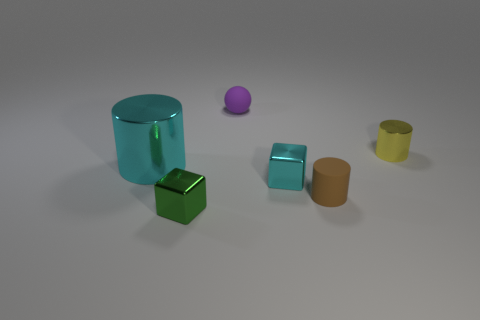Subtract all large cylinders. How many cylinders are left? 2 Add 3 small spheres. How many objects exist? 9 Subtract all balls. How many objects are left? 5 Subtract 2 cylinders. How many cylinders are left? 1 Add 1 rubber balls. How many rubber balls are left? 2 Add 3 purple matte things. How many purple matte things exist? 4 Subtract 0 red cubes. How many objects are left? 6 Subtract all brown cylinders. Subtract all green balls. How many cylinders are left? 2 Subtract all cubes. Subtract all small shiny cubes. How many objects are left? 2 